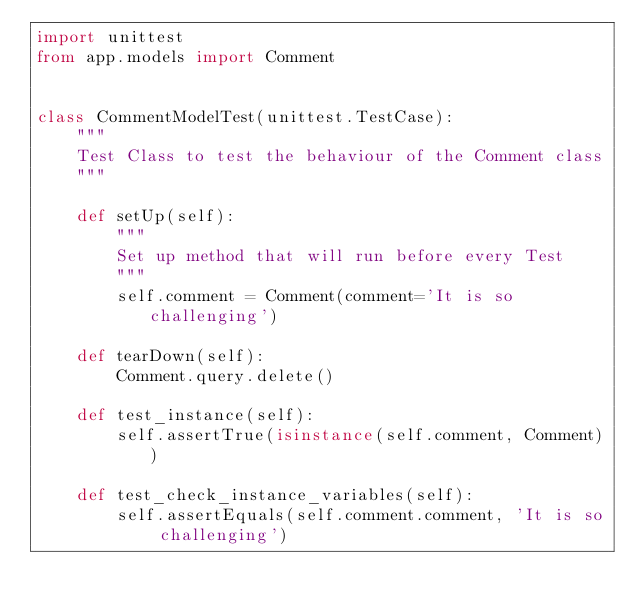<code> <loc_0><loc_0><loc_500><loc_500><_Python_>import unittest
from app.models import Comment


class CommentModelTest(unittest.TestCase):
    """
    Test Class to test the behaviour of the Comment class
    """

    def setUp(self):
        """
        Set up method that will run before every Test
        """
        self.comment = Comment(comment='It is so challenging')

    def tearDown(self):
        Comment.query.delete()

    def test_instance(self):
        self.assertTrue(isinstance(self.comment, Comment))

    def test_check_instance_variables(self):
        self.assertEquals(self.comment.comment, 'It is so challenging')
</code> 